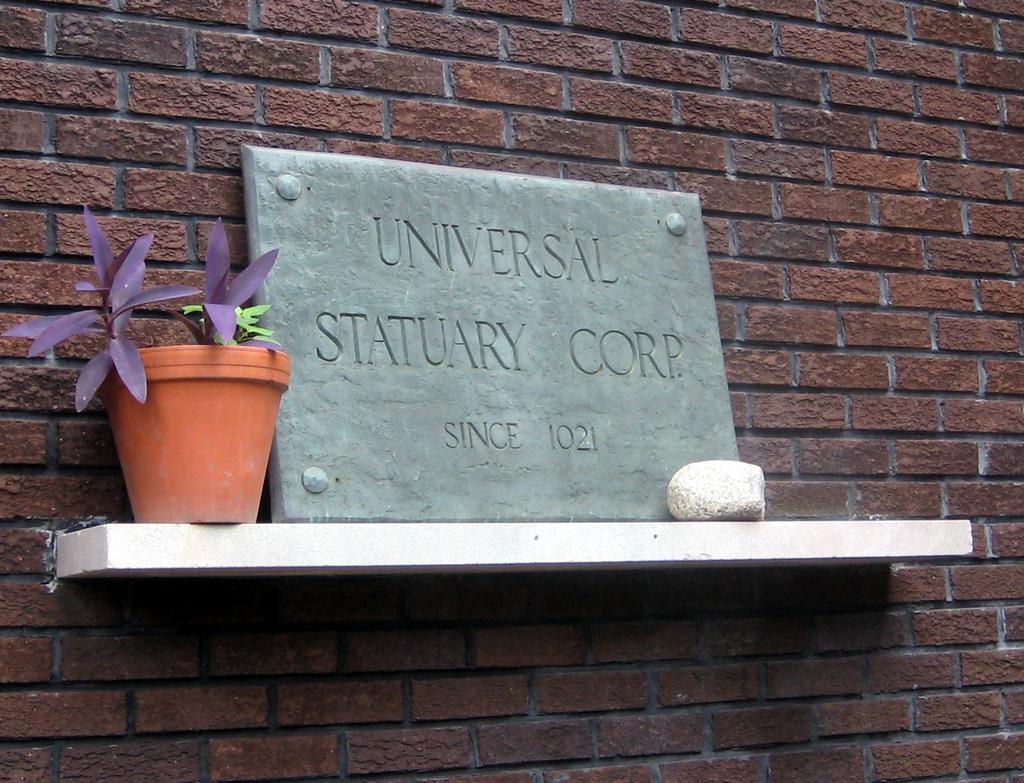In one or two sentences, can you explain what this image depicts? In the center of the image there is a brick wall. And we can see one wooden object. On the wooden object, we can see one stone, one plant pot, plant, one stone banner etc. On the banner, we can see some text. 